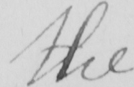What does this handwritten line say? the 